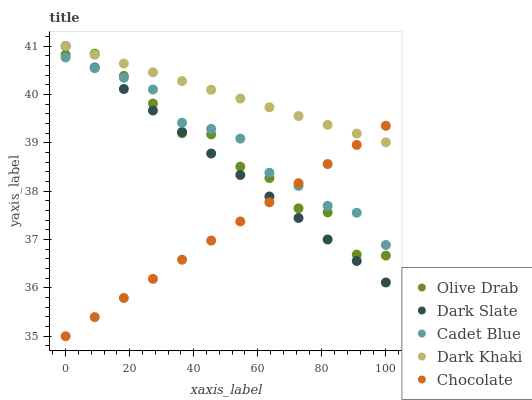Does Chocolate have the minimum area under the curve?
Answer yes or no. Yes. Does Dark Khaki have the maximum area under the curve?
Answer yes or no. Yes. Does Dark Slate have the minimum area under the curve?
Answer yes or no. No. Does Dark Slate have the maximum area under the curve?
Answer yes or no. No. Is Dark Khaki the smoothest?
Answer yes or no. Yes. Is Olive Drab the roughest?
Answer yes or no. Yes. Is Dark Slate the smoothest?
Answer yes or no. No. Is Dark Slate the roughest?
Answer yes or no. No. Does Chocolate have the lowest value?
Answer yes or no. Yes. Does Dark Slate have the lowest value?
Answer yes or no. No. Does Dark Slate have the highest value?
Answer yes or no. Yes. Does Cadet Blue have the highest value?
Answer yes or no. No. Is Cadet Blue less than Dark Khaki?
Answer yes or no. Yes. Is Dark Khaki greater than Cadet Blue?
Answer yes or no. Yes. Does Chocolate intersect Cadet Blue?
Answer yes or no. Yes. Is Chocolate less than Cadet Blue?
Answer yes or no. No. Is Chocolate greater than Cadet Blue?
Answer yes or no. No. Does Cadet Blue intersect Dark Khaki?
Answer yes or no. No. 